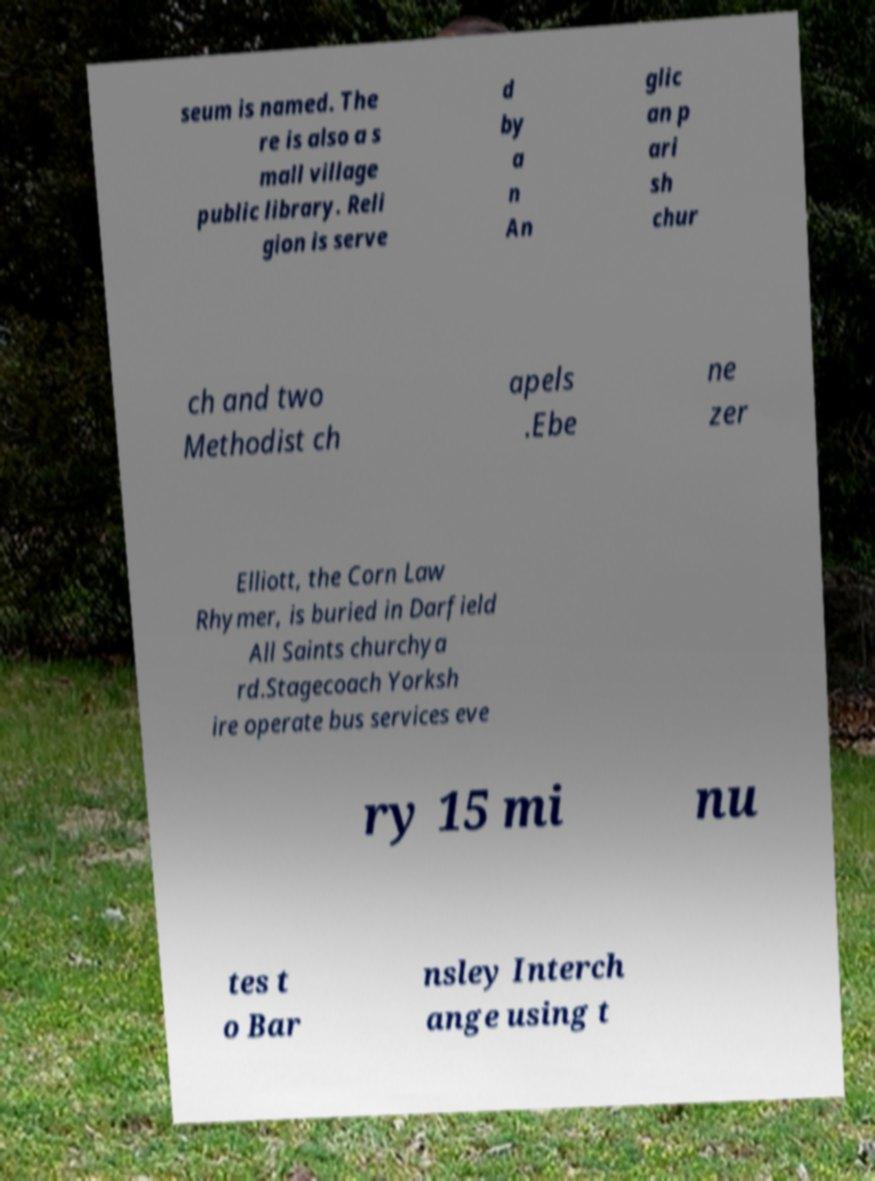Please read and relay the text visible in this image. What does it say? seum is named. The re is also a s mall village public library. Reli gion is serve d by a n An glic an p ari sh chur ch and two Methodist ch apels .Ebe ne zer Elliott, the Corn Law Rhymer, is buried in Darfield All Saints churchya rd.Stagecoach Yorksh ire operate bus services eve ry 15 mi nu tes t o Bar nsley Interch ange using t 